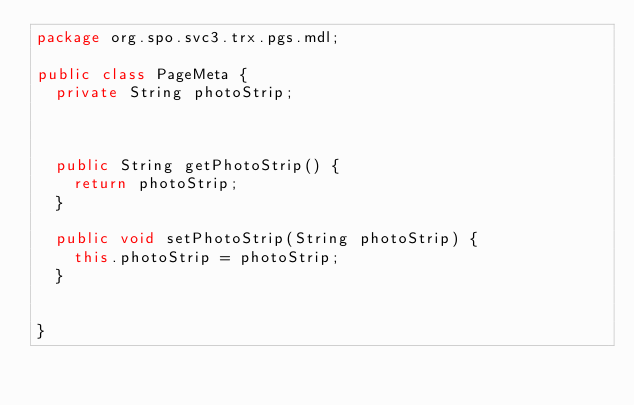<code> <loc_0><loc_0><loc_500><loc_500><_Java_>package org.spo.svc3.trx.pgs.mdl;

public class PageMeta {
	private String photoStrip;
	

	
	public String getPhotoStrip() {
		return photoStrip;
	}

	public void setPhotoStrip(String photoStrip) {
		this.photoStrip = photoStrip;
	}
	

}
</code> 